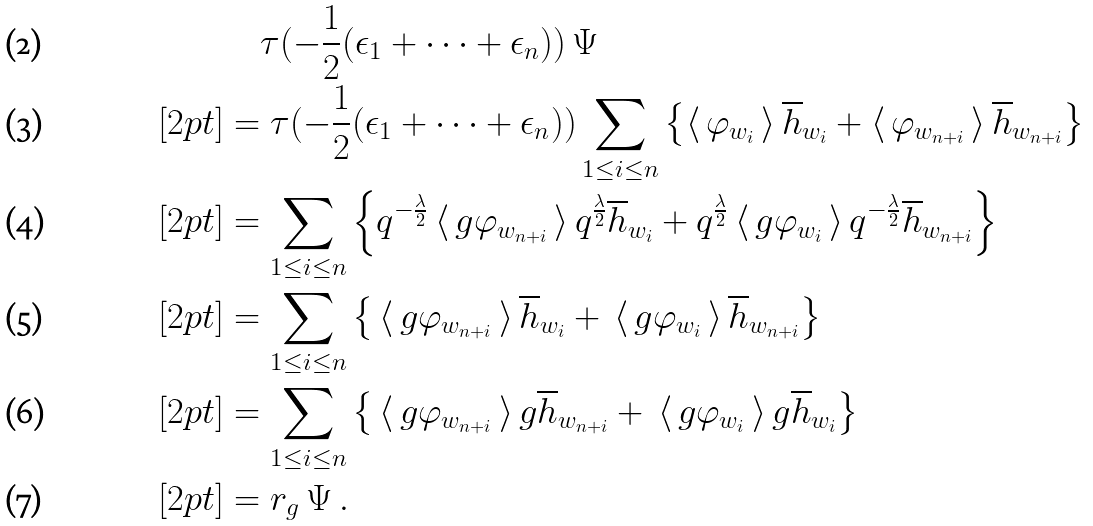Convert formula to latex. <formula><loc_0><loc_0><loc_500><loc_500>& \quad \tau ( - \frac { 1 } { 2 } ( \epsilon _ { 1 } + \cdots + \epsilon _ { n } ) ) \, \Psi \\ [ 2 p t ] & = \tau ( - \frac { 1 } { 2 } ( \epsilon _ { 1 } + \cdots + \epsilon _ { n } ) ) \sum _ { 1 \leq i \leq n } \left \{ \langle \, \varphi _ { w _ { i } } \, \rangle \, \overline { h } _ { w _ { i } } + \langle \, \varphi _ { w _ { n + i } } \, \rangle \, \overline { h } _ { w _ { n + i } } \right \} \\ [ 2 p t ] & = \sum _ { 1 \leq i \leq n } \left \{ q ^ { - \frac { \lambda } { 2 } } \, \langle \, g \varphi _ { w _ { n + i } } \, \rangle \, q ^ { \frac { \lambda } { 2 } } \overline { h } _ { w _ { i } } + q ^ { \frac { \lambda } { 2 } } \, \langle \, g \varphi _ { w _ { i } } \, \rangle \, q ^ { - \frac { \lambda } { 2 } } \overline { h } _ { w _ { n + i } } \right \} \\ [ 2 p t ] & = \sum _ { 1 \leq i \leq n } \left \{ \, \langle \, g \varphi _ { w _ { n + i } } \, \rangle \, \overline { h } _ { w _ { i } } + \, \langle \, g \varphi _ { w _ { i } } \, \rangle \, \overline { h } _ { w _ { n + i } } \right \} \\ [ 2 p t ] & = \sum _ { 1 \leq i \leq n } \left \{ \, \langle \, g \varphi _ { w _ { n + i } } \, \rangle \, g \overline { h } _ { w _ { n + i } } + \, \langle \, g \varphi _ { w _ { i } } \, \rangle \, g \overline { h } _ { w _ { i } } \right \} \\ [ 2 p t ] & = r _ { g } \, \Psi \, .</formula> 